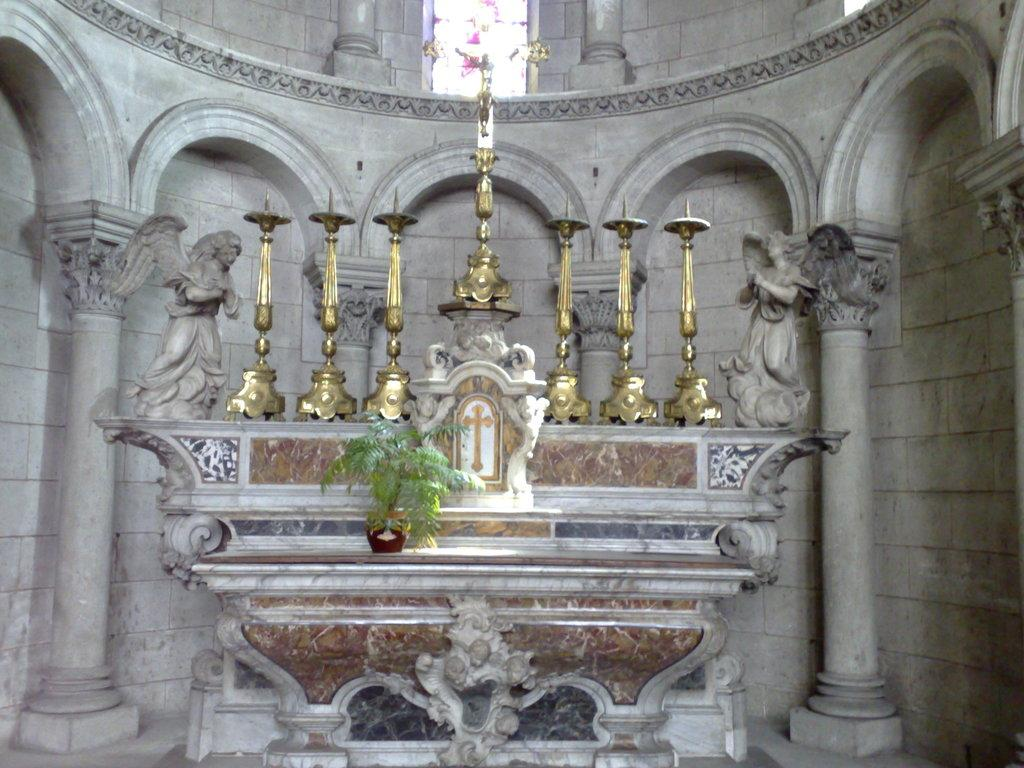What is located in the front of the image? There is a plant in the front of the image. What can be seen behind the plant? There are golden color candle stands behind the plant. What decorative elements are present on both sides of the image? There are sculptures on both sides of the image. What type of leather material is used for the plant's pot in the image? There is no leather material present in the image, as the plant is in a pot made of unspecified material. 